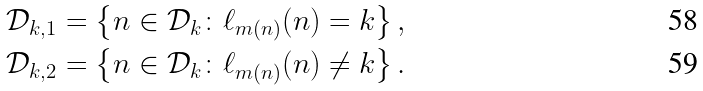Convert formula to latex. <formula><loc_0><loc_0><loc_500><loc_500>\mathcal { D } _ { k , 1 } = \left \{ n \in \mathcal { D } _ { k } \colon \ell _ { m ( n ) } ( n ) = k \right \} , \\ \mathcal { D } _ { k , 2 } = \left \{ n \in \mathcal { D } _ { k } \colon \ell _ { m ( n ) } ( n ) \neq k \right \} .</formula> 